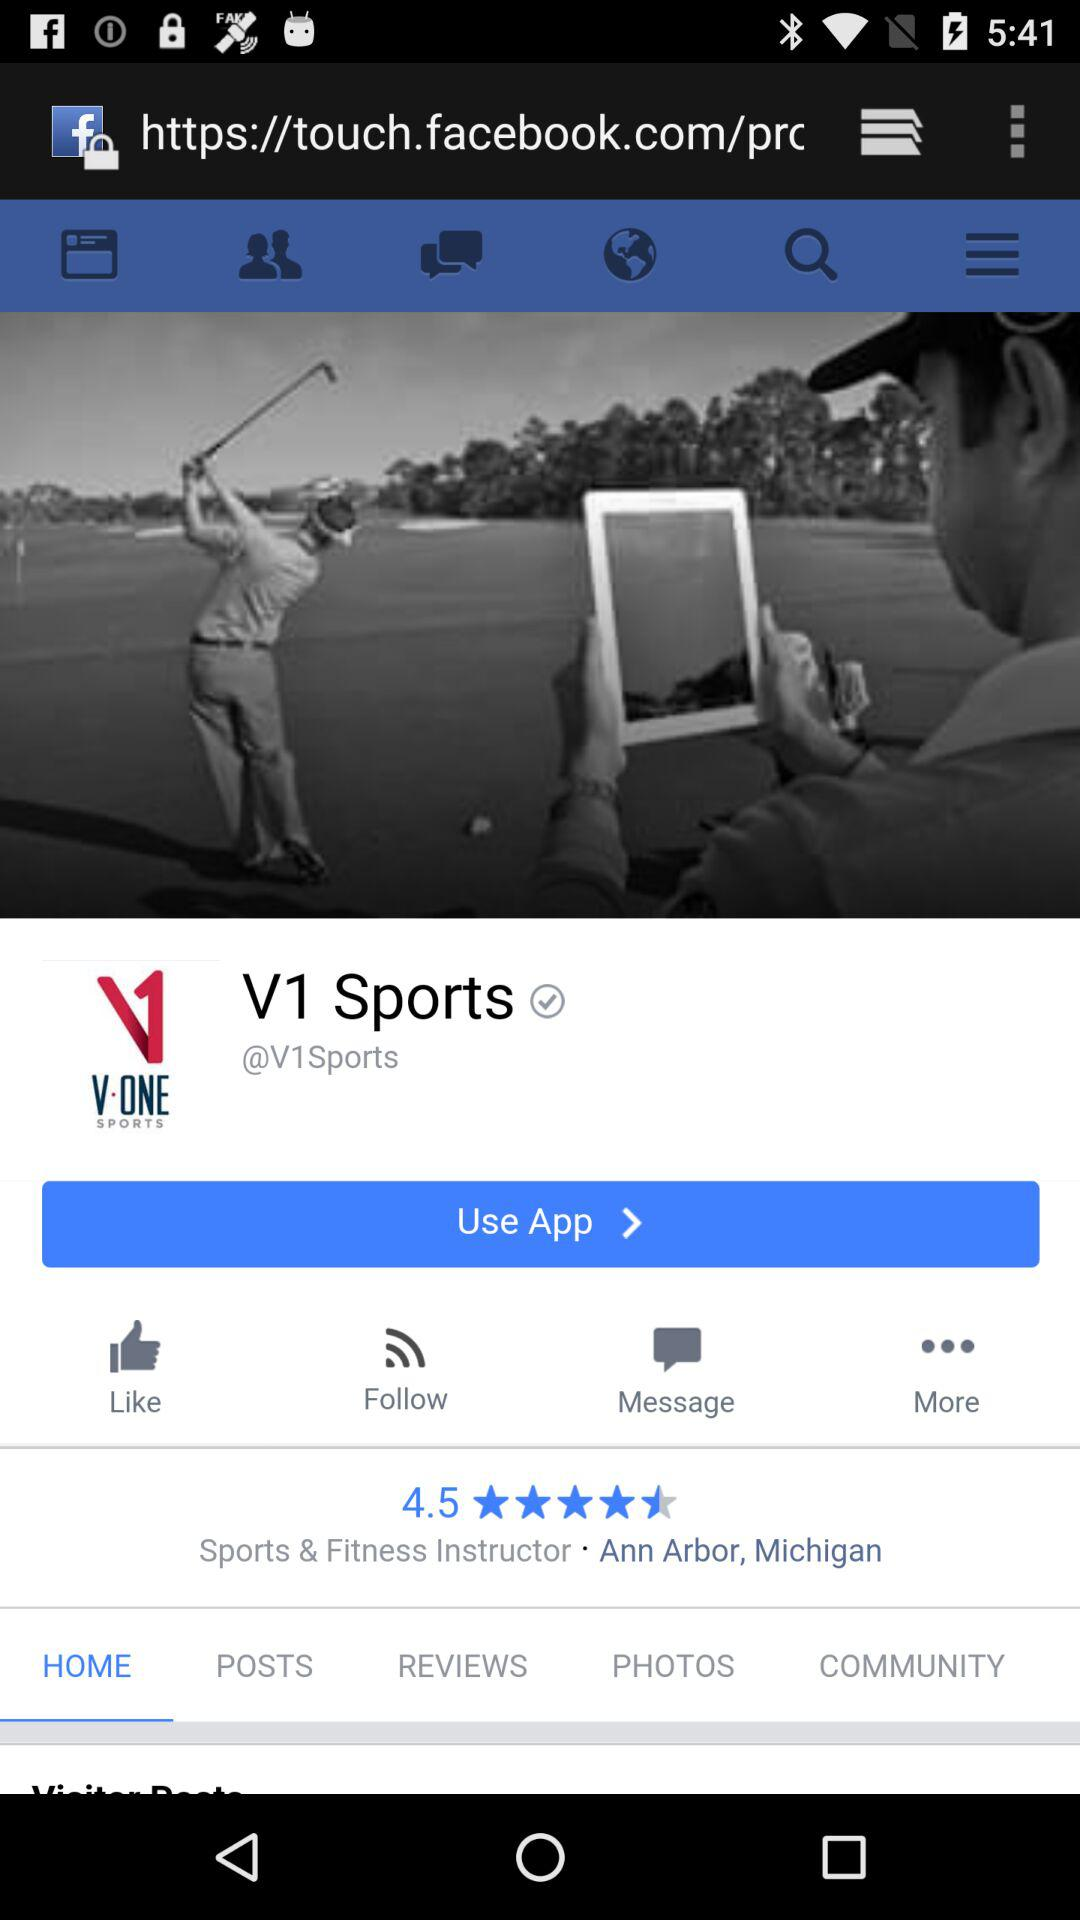What is the rating for the "V1 Sports" application? The rating for the "V1 Sports" application is 4.5. 